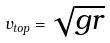<formula> <loc_0><loc_0><loc_500><loc_500>v _ { t o p } = \sqrt { g r }</formula> 